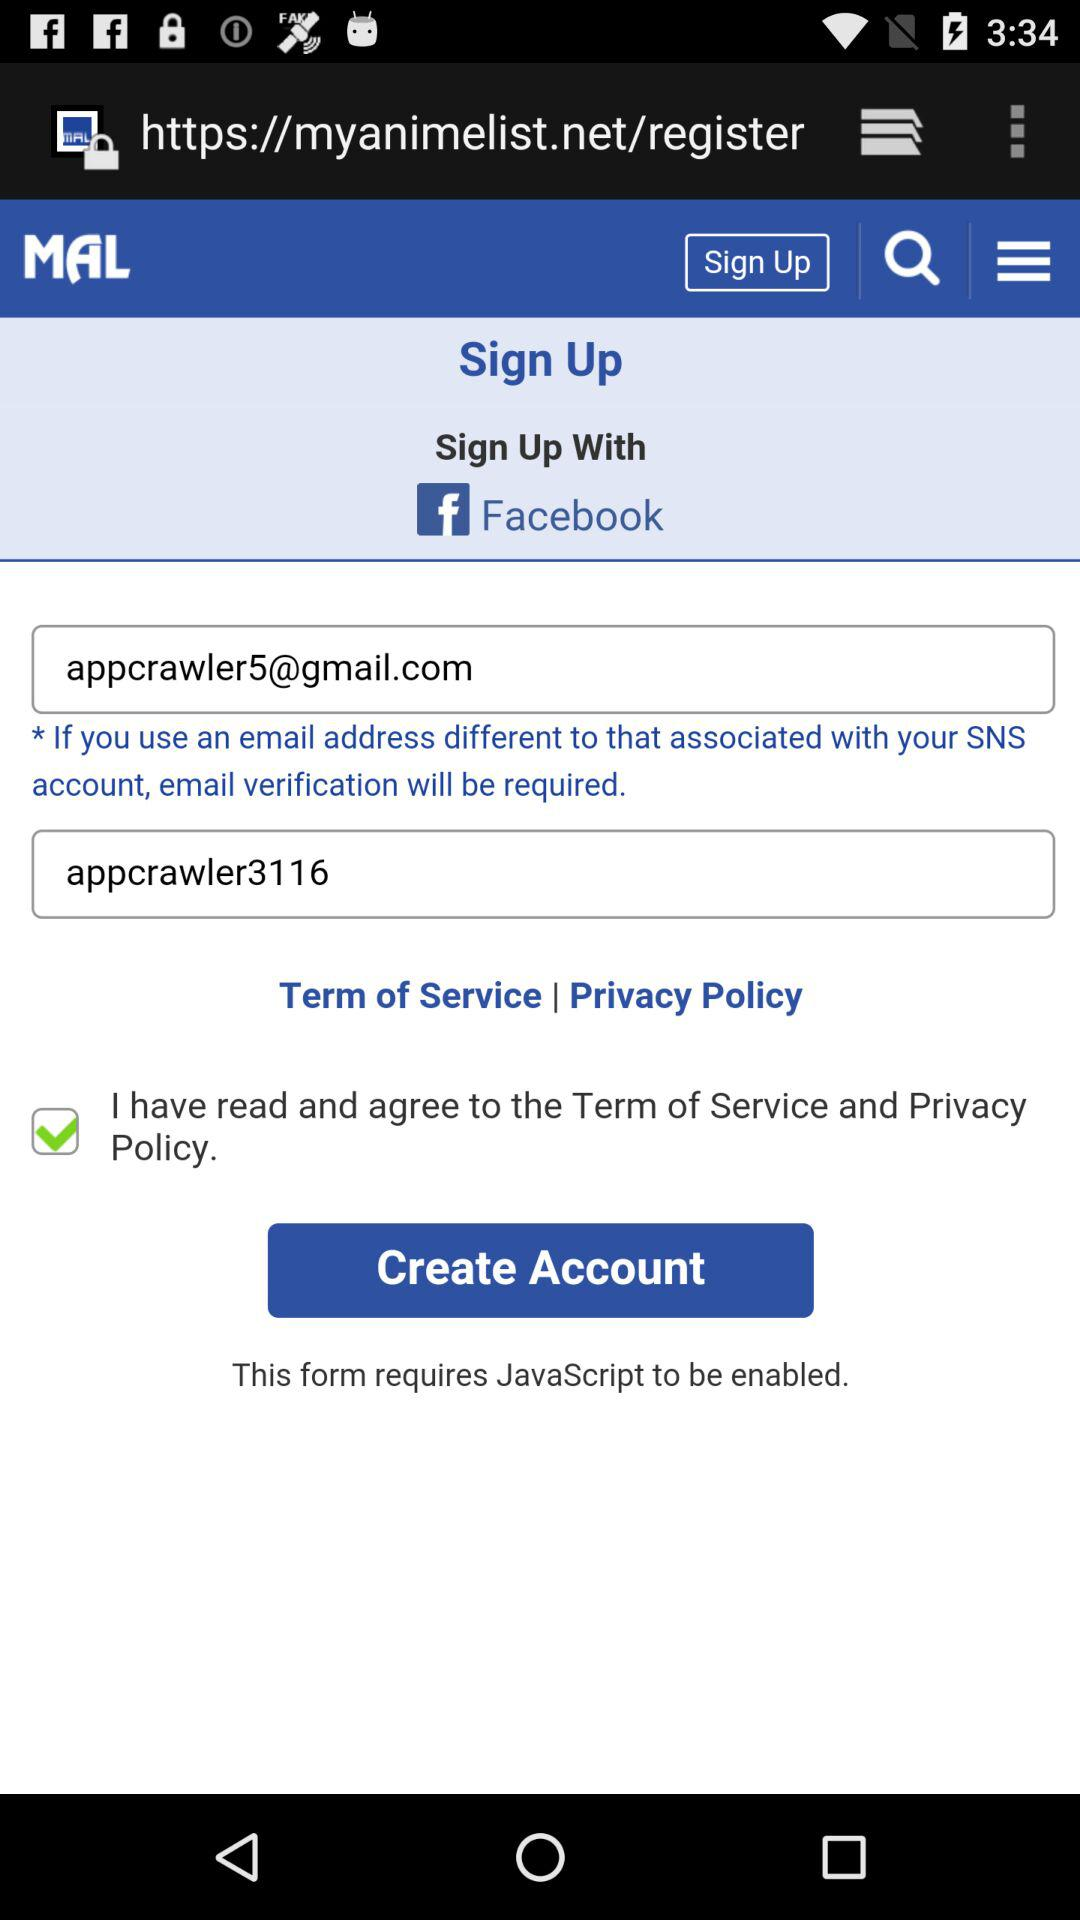What is the given email address? The given email address is appcrawler5@gmail.com. 